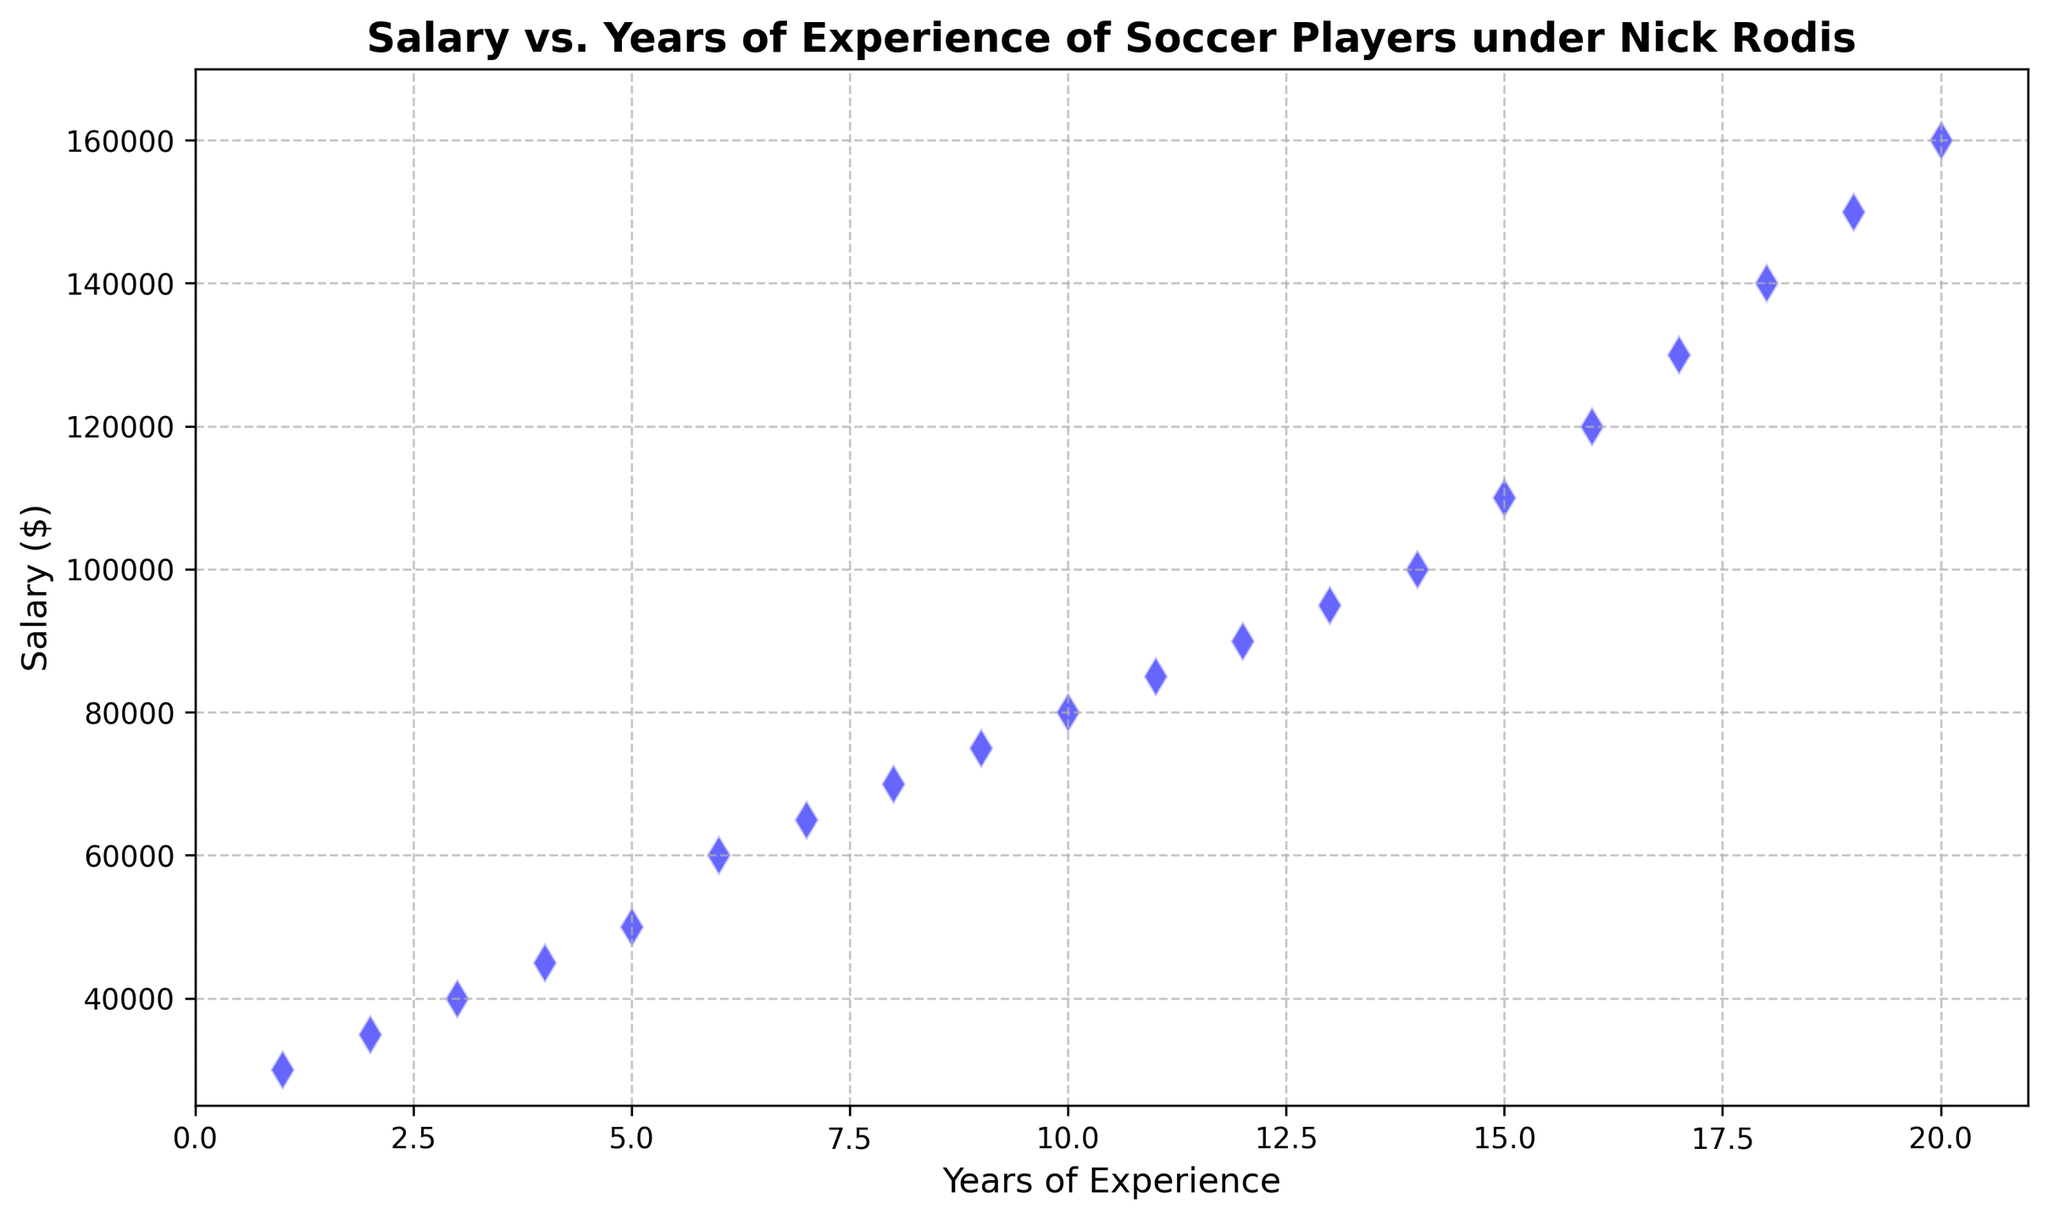What is the average salary for players with less than 10 years of experience? To find the average salary, sum the salaries of players with 1 to 9 years of experience: 30000 + 35000 + 40000 + 45000 + 50000 + 60000 + 65000 + 70000 + 75000 = 470000. There are 9 players in this category, so the average is 470000 / 9.
Answer: 52222.22 Which player has the highest salary and how many years of experience do they have? The plot shows that the highest salary is $160,000, corresponding to the player with 20 years of experience.
Answer: 20 years How much more does a player with 15 years of experience make compared to a player with 5 years of experience? A player with 15 years makes $110,000 and a player with 5 years makes $50,000. The difference is 110000 - 50000.
Answer: 60000 Is the salary growth linear with years of experience? Looking at the plot, we see a clear, consistent upward trend that suggests a linear relationship between salary and years of experience.
Answer: Yes What is the median salary for players under Nick Rodis? To find the median salary, list all salaries in ascending order, and pick the middle value(s). There are 20 data points, so the median will be the average of the 10th and 11th values, i.e., (80000 + 85000) / 2.
Answer: 82500 How much more does a player with 18 years of experience make compared to a player with 9 years of experience? A player with 18 years makes $140,000 and a player with 9 years makes $75,000. The difference is 140000 - 75000.
Answer: 65000 What is the total salary difference between players with the minimum and maximum years of experience? The minimum years of experience is 1 year with a salary of $30,000, and the maximum is 20 years with a salary of $160,000. The difference is 160000 - 30000.
Answer: 130000 Are there any players making the same salary despite having different years of experience? The plot does not show any overlapping points, indicating that each player's salary is unique relative to their years of experience.
Answer: No What is the average salary increase per year of experience? To find the annual salary increase, use the difference in salary between players with 20 years and 1 year of experience: 160000 - 30000, then divide by the difference in experience (20 - 1).
Answer: 6842.11 